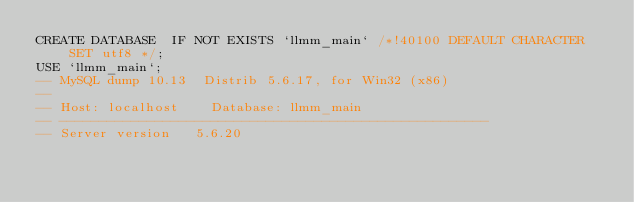<code> <loc_0><loc_0><loc_500><loc_500><_SQL_>CREATE DATABASE  IF NOT EXISTS `llmm_main` /*!40100 DEFAULT CHARACTER SET utf8 */;
USE `llmm_main`;
-- MySQL dump 10.13  Distrib 5.6.17, for Win32 (x86)
--
-- Host: localhost    Database: llmm_main
-- ------------------------------------------------------
-- Server version	5.6.20
</code> 